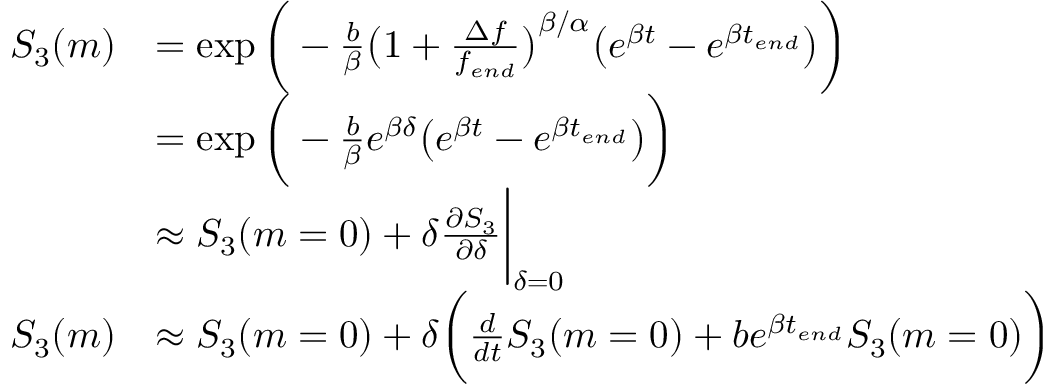<formula> <loc_0><loc_0><loc_500><loc_500>\begin{array} { r l } { S _ { 3 } ( m ) } & { = \exp { \Big ( - \frac { b } { \beta } \Big ( 1 + \frac { \Delta f } { { f _ { e n d } } } \Big ) ^ { \beta / \alpha } \Big ( e ^ { \beta t } - e ^ { \beta t _ { e n d } } \Big ) \Big ) } } \\ & { = \exp { \Big ( - \frac { b } { \beta } e ^ { \beta \delta } \Big ( e ^ { \beta t } - e ^ { \beta t _ { e n d } } \Big ) \Big ) } } \\ & { \approx S _ { 3 } ( m = 0 ) + \delta \frac { \partial S _ { 3 } } { \partial \delta } \Big | _ { \delta = 0 } } \\ { S _ { 3 } ( m ) } & { \approx S _ { 3 } ( m = 0 ) + \delta \Big ( \frac { d } { d t } S _ { 3 } ( m = 0 ) + b e ^ { \beta t _ { e n d } } S _ { 3 } ( m = 0 ) \Big ) } \end{array}</formula> 